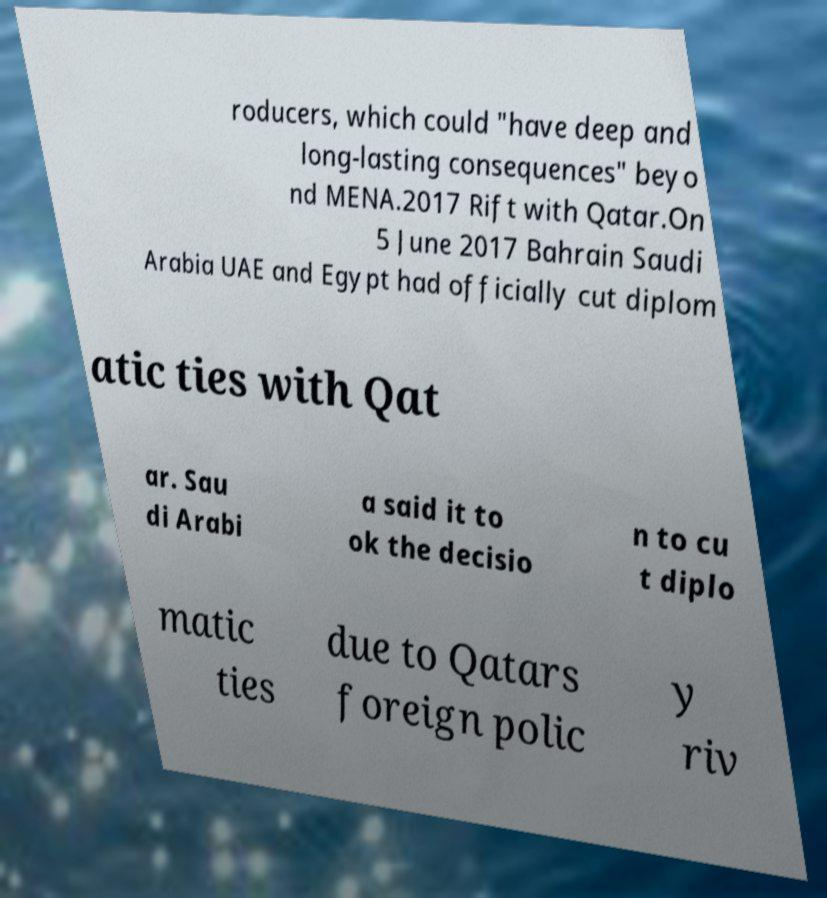What messages or text are displayed in this image? I need them in a readable, typed format. roducers, which could "have deep and long-lasting consequences" beyo nd MENA.2017 Rift with Qatar.On 5 June 2017 Bahrain Saudi Arabia UAE and Egypt had officially cut diplom atic ties with Qat ar. Sau di Arabi a said it to ok the decisio n to cu t diplo matic ties due to Qatars foreign polic y riv 